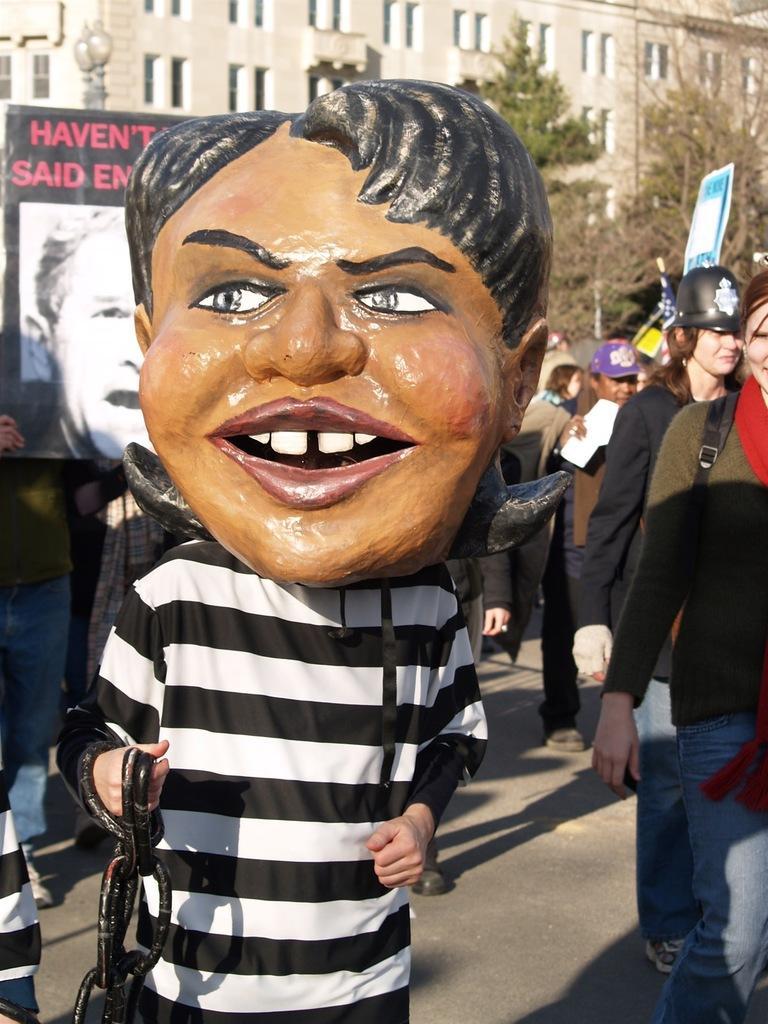Please provide a concise description of this image. In front of the image there is a person holding an object in his hand is wearing a mask on his face, behind him there are a few other people holding placards in their hands, behind them there are lamp posts, trees and buildings. 